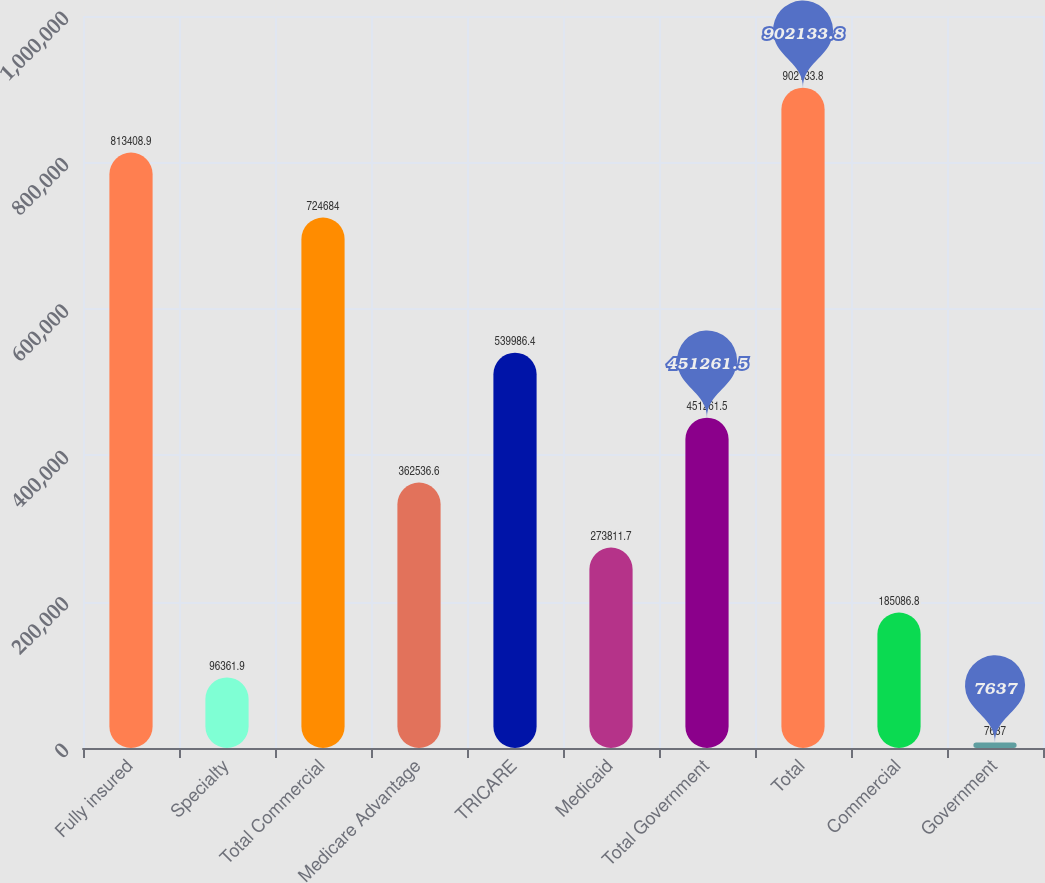Convert chart. <chart><loc_0><loc_0><loc_500><loc_500><bar_chart><fcel>Fully insured<fcel>Specialty<fcel>Total Commercial<fcel>Medicare Advantage<fcel>TRICARE<fcel>Medicaid<fcel>Total Government<fcel>Total<fcel>Commercial<fcel>Government<nl><fcel>813409<fcel>96361.9<fcel>724684<fcel>362537<fcel>539986<fcel>273812<fcel>451262<fcel>902134<fcel>185087<fcel>7637<nl></chart> 